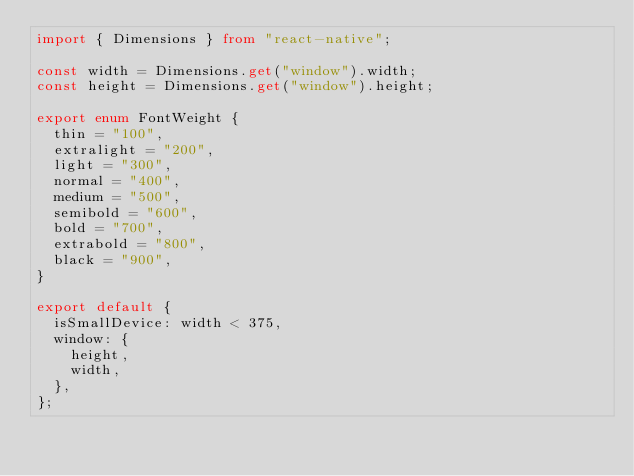<code> <loc_0><loc_0><loc_500><loc_500><_TypeScript_>import { Dimensions } from "react-native";

const width = Dimensions.get("window").width;
const height = Dimensions.get("window").height;

export enum FontWeight {
  thin = "100",
  extralight = "200",
  light = "300",
  normal = "400",
  medium = "500",
  semibold = "600",
  bold = "700",
  extrabold = "800",
  black = "900",
}

export default {
  isSmallDevice: width < 375,
  window: {
    height,
    width,
  },
};
</code> 